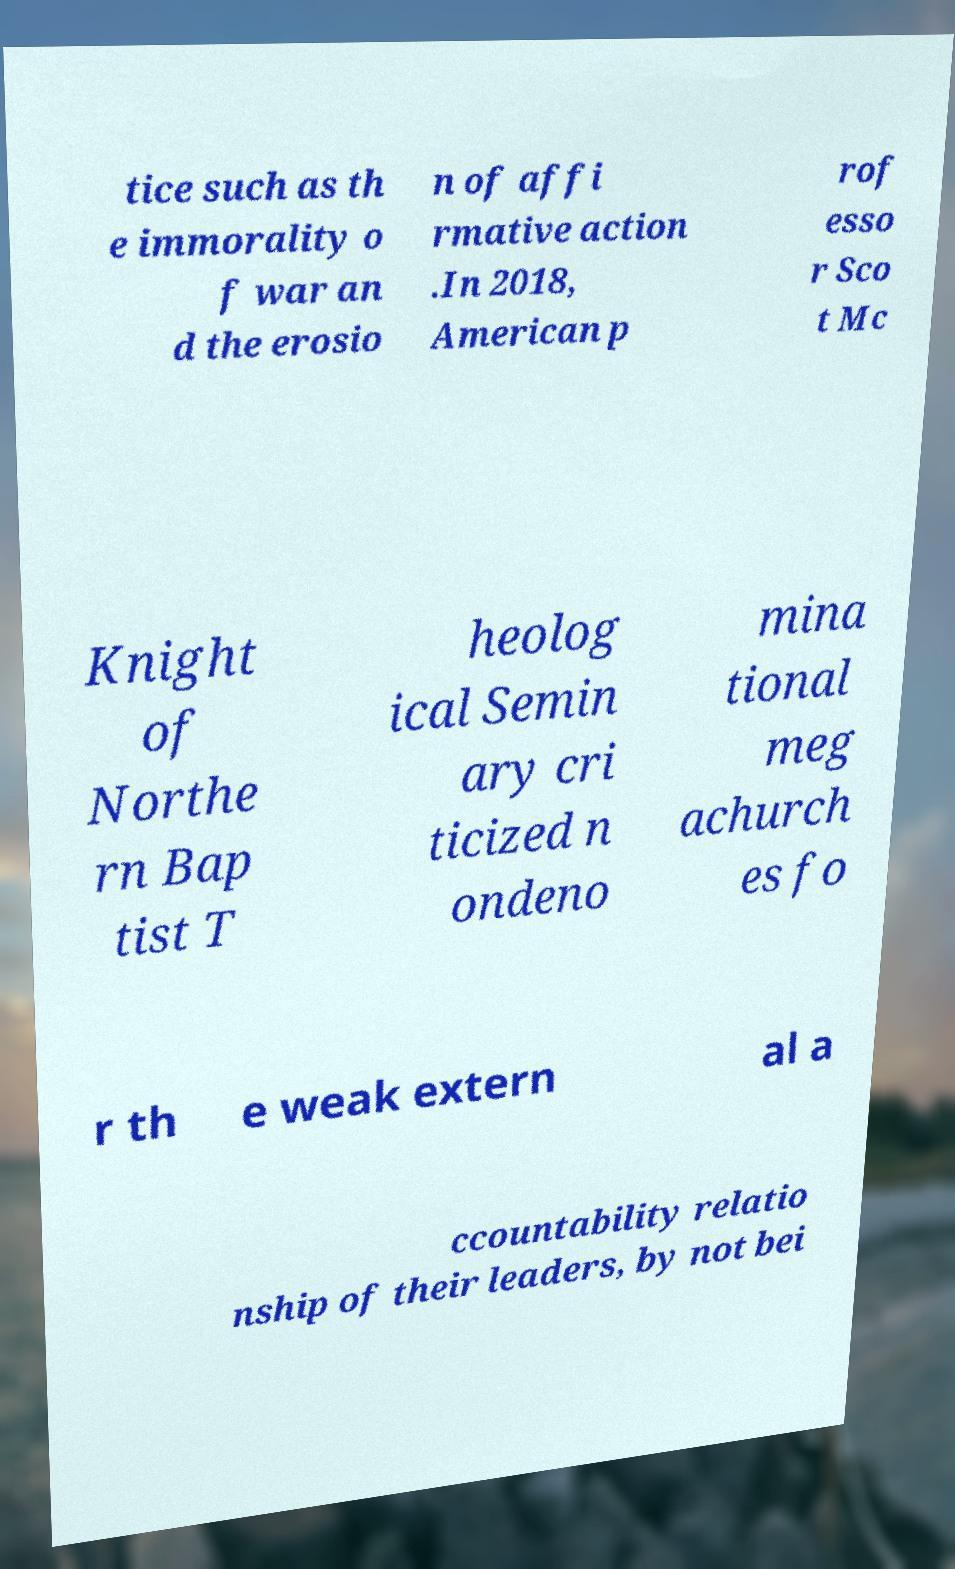I need the written content from this picture converted into text. Can you do that? tice such as th e immorality o f war an d the erosio n of affi rmative action .In 2018, American p rof esso r Sco t Mc Knight of Northe rn Bap tist T heolog ical Semin ary cri ticized n ondeno mina tional meg achurch es fo r th e weak extern al a ccountability relatio nship of their leaders, by not bei 